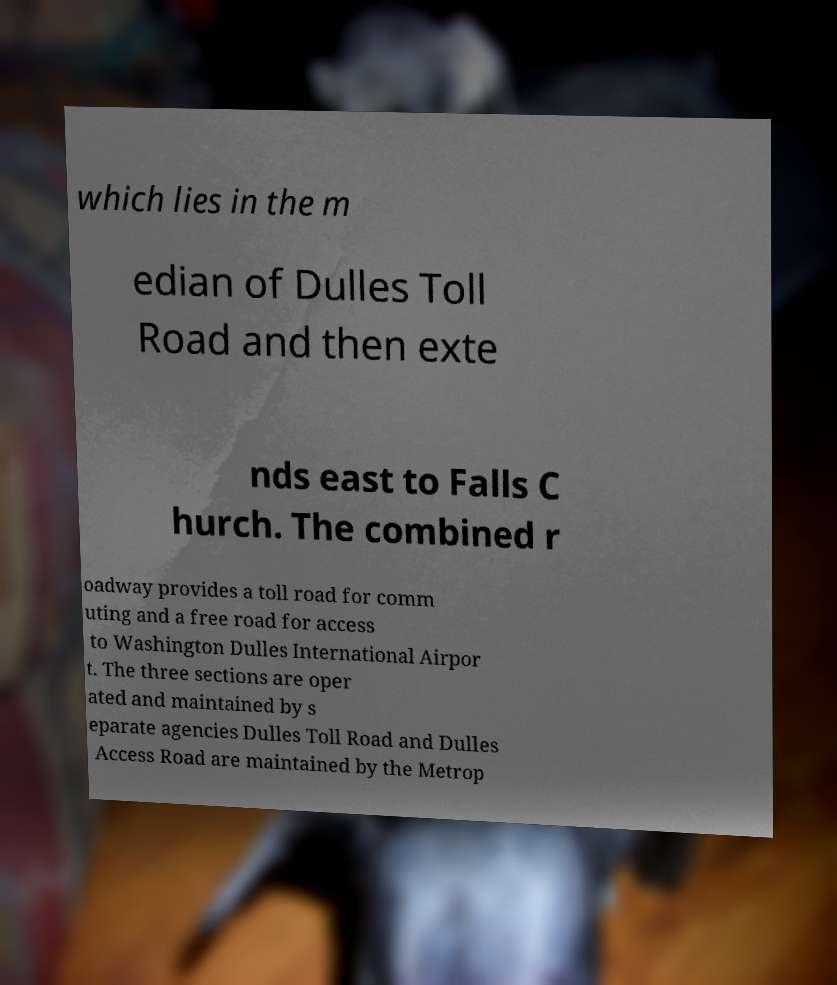I need the written content from this picture converted into text. Can you do that? which lies in the m edian of Dulles Toll Road and then exte nds east to Falls C hurch. The combined r oadway provides a toll road for comm uting and a free road for access to Washington Dulles International Airpor t. The three sections are oper ated and maintained by s eparate agencies Dulles Toll Road and Dulles Access Road are maintained by the Metrop 